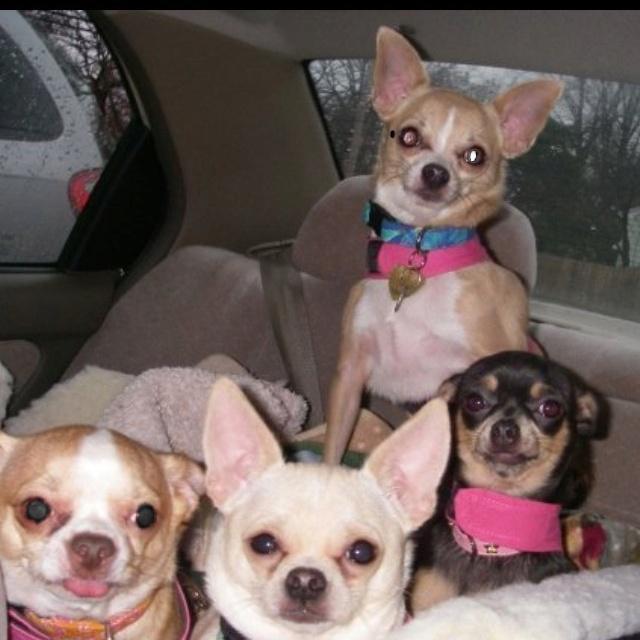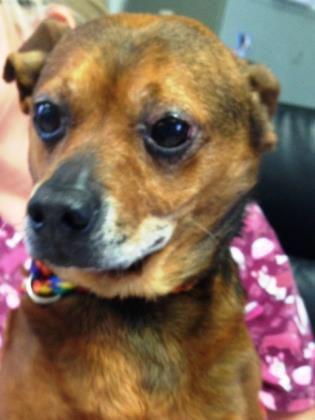The first image is the image on the left, the second image is the image on the right. Given the left and right images, does the statement "One image shows one tan dog wearing a collar, and the other image includes at least one chihuahua wearing something hot pink." hold true? Answer yes or no. Yes. The first image is the image on the left, the second image is the image on the right. Given the left and right images, does the statement "There are four dogs in one image and the other has only one." hold true? Answer yes or no. Yes. 